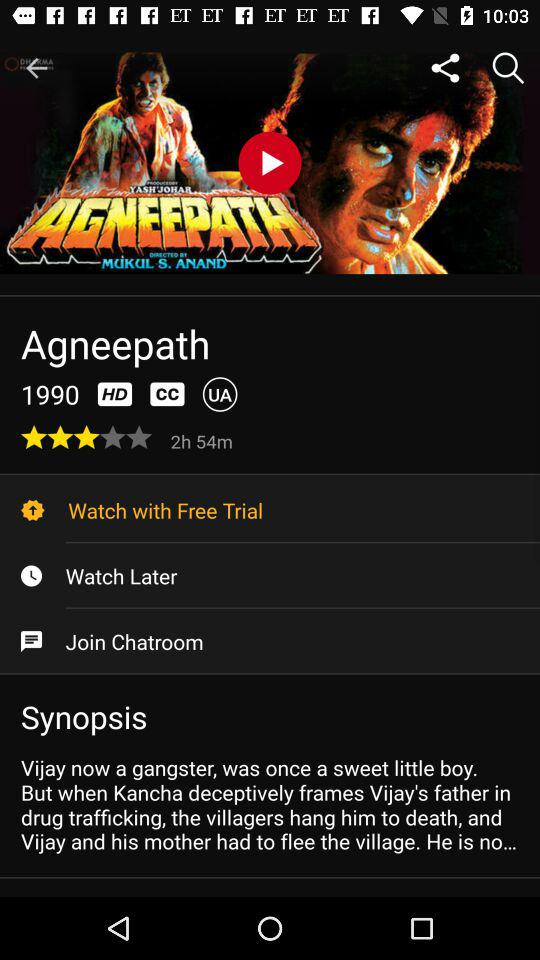What is the given year? The given year is 1990. 